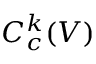Convert formula to latex. <formula><loc_0><loc_0><loc_500><loc_500>C _ { c } ^ { k } ( V )</formula> 